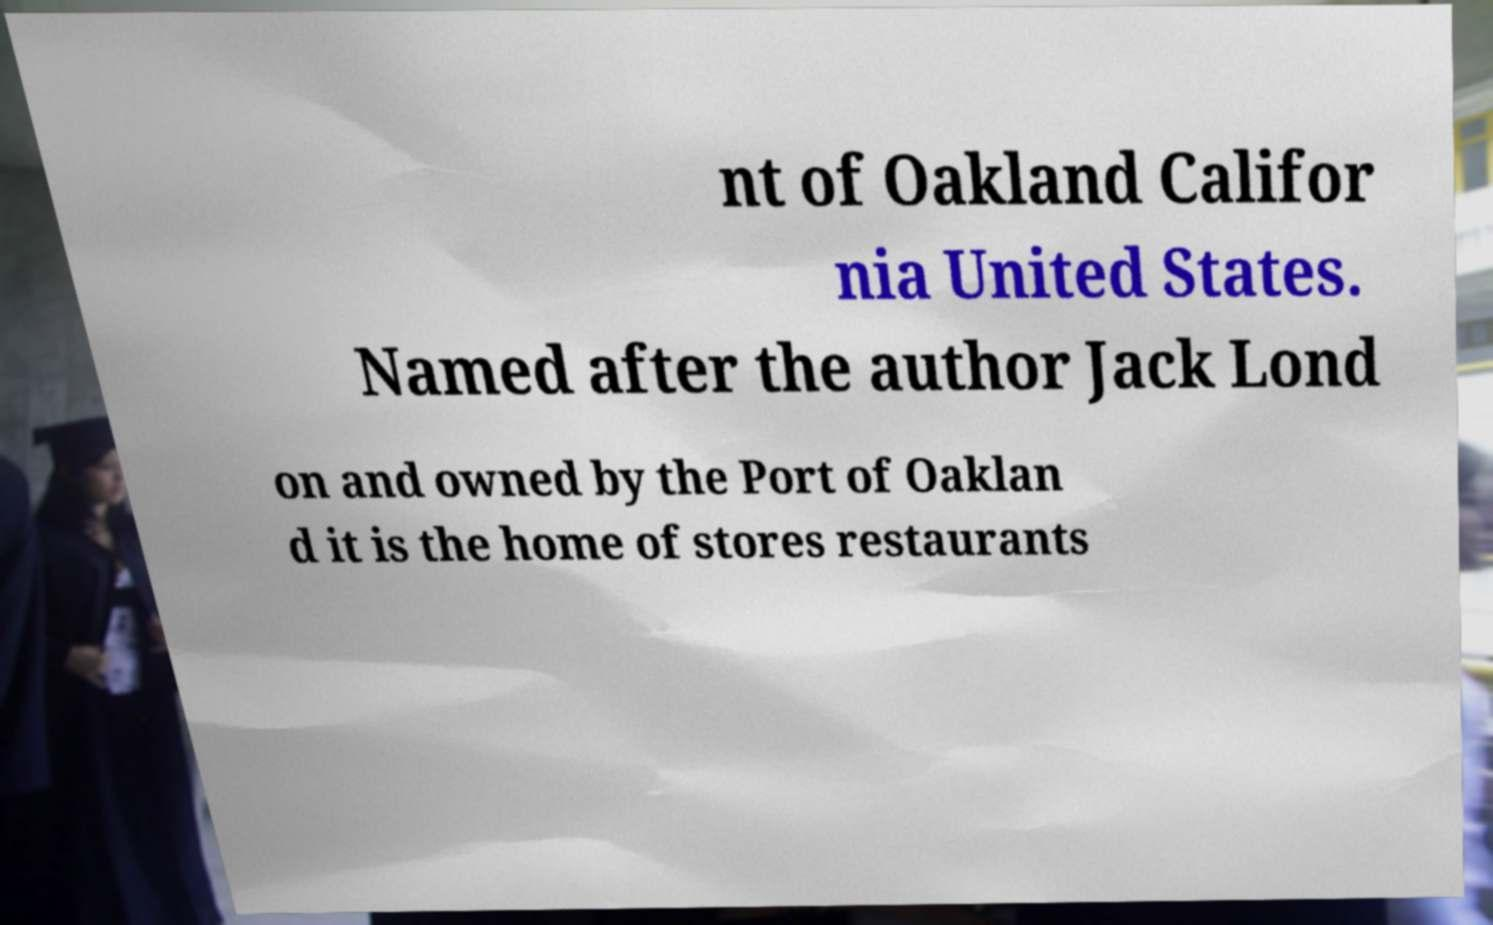Could you extract and type out the text from this image? nt of Oakland Califor nia United States. Named after the author Jack Lond on and owned by the Port of Oaklan d it is the home of stores restaurants 